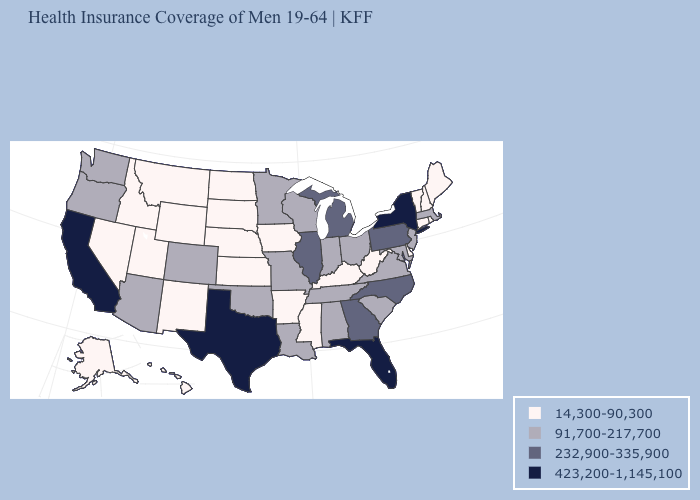Which states have the lowest value in the USA?
Give a very brief answer. Alaska, Arkansas, Connecticut, Delaware, Hawaii, Idaho, Iowa, Kansas, Kentucky, Maine, Mississippi, Montana, Nebraska, Nevada, New Hampshire, New Mexico, North Dakota, Rhode Island, South Dakota, Utah, Vermont, West Virginia, Wyoming. What is the value of New York?
Give a very brief answer. 423,200-1,145,100. Is the legend a continuous bar?
Short answer required. No. What is the highest value in the South ?
Quick response, please. 423,200-1,145,100. Among the states that border Oklahoma , does New Mexico have the lowest value?
Keep it brief. Yes. Does Florida have the highest value in the South?
Give a very brief answer. Yes. Which states have the lowest value in the USA?
Short answer required. Alaska, Arkansas, Connecticut, Delaware, Hawaii, Idaho, Iowa, Kansas, Kentucky, Maine, Mississippi, Montana, Nebraska, Nevada, New Hampshire, New Mexico, North Dakota, Rhode Island, South Dakota, Utah, Vermont, West Virginia, Wyoming. What is the value of Georgia?
Answer briefly. 232,900-335,900. Does Florida have the highest value in the South?
Be succinct. Yes. Name the states that have a value in the range 14,300-90,300?
Answer briefly. Alaska, Arkansas, Connecticut, Delaware, Hawaii, Idaho, Iowa, Kansas, Kentucky, Maine, Mississippi, Montana, Nebraska, Nevada, New Hampshire, New Mexico, North Dakota, Rhode Island, South Dakota, Utah, Vermont, West Virginia, Wyoming. Name the states that have a value in the range 423,200-1,145,100?
Quick response, please. California, Florida, New York, Texas. What is the lowest value in states that border Oklahoma?
Concise answer only. 14,300-90,300. Does West Virginia have a lower value than Missouri?
Answer briefly. Yes. What is the value of New Mexico?
Short answer required. 14,300-90,300. 